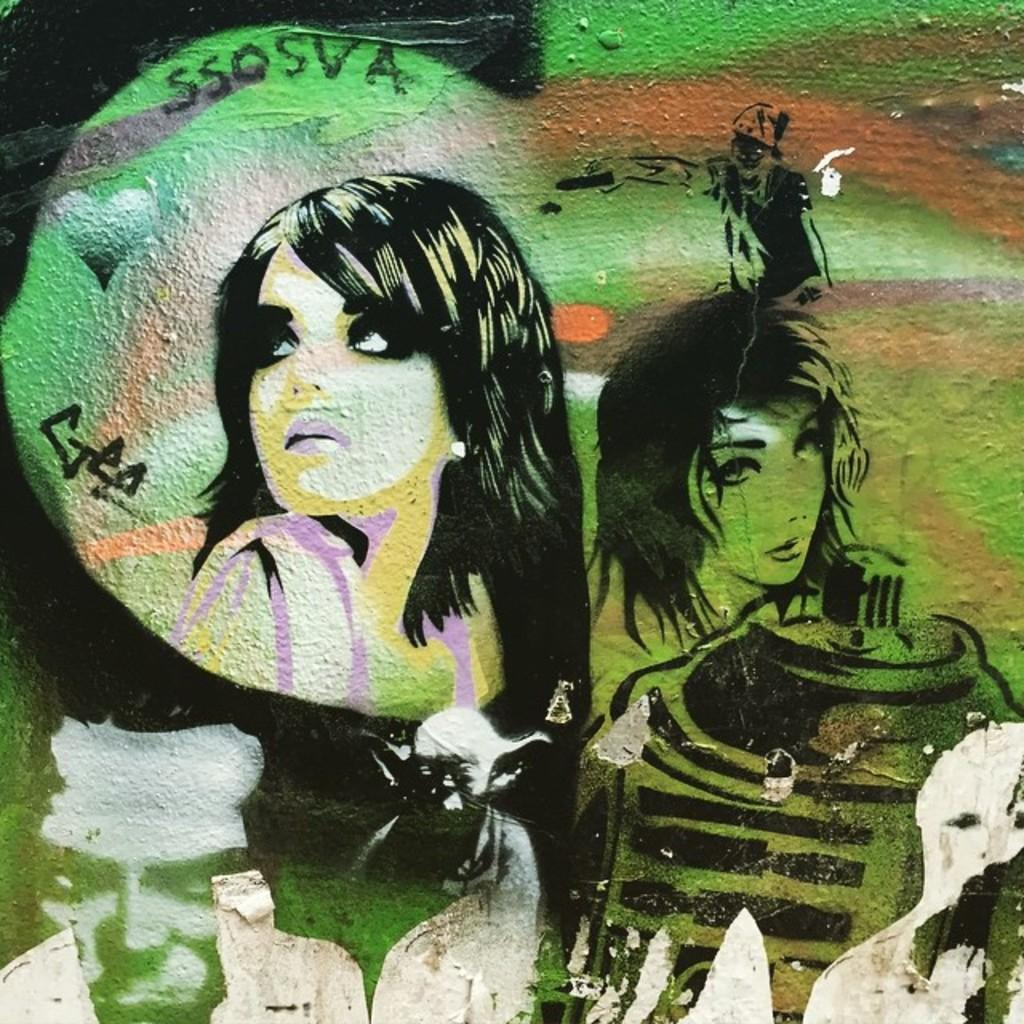What is present on the wall in the image? There is a painting on the wall in the image. What does the painting depict? The painting depicts a few persons. What colors are used in the painting? The painting has green, black, and white colors. What is the name of the doll in the painting? There are no dolls present in the image or the painting; it depicts a few persons. 